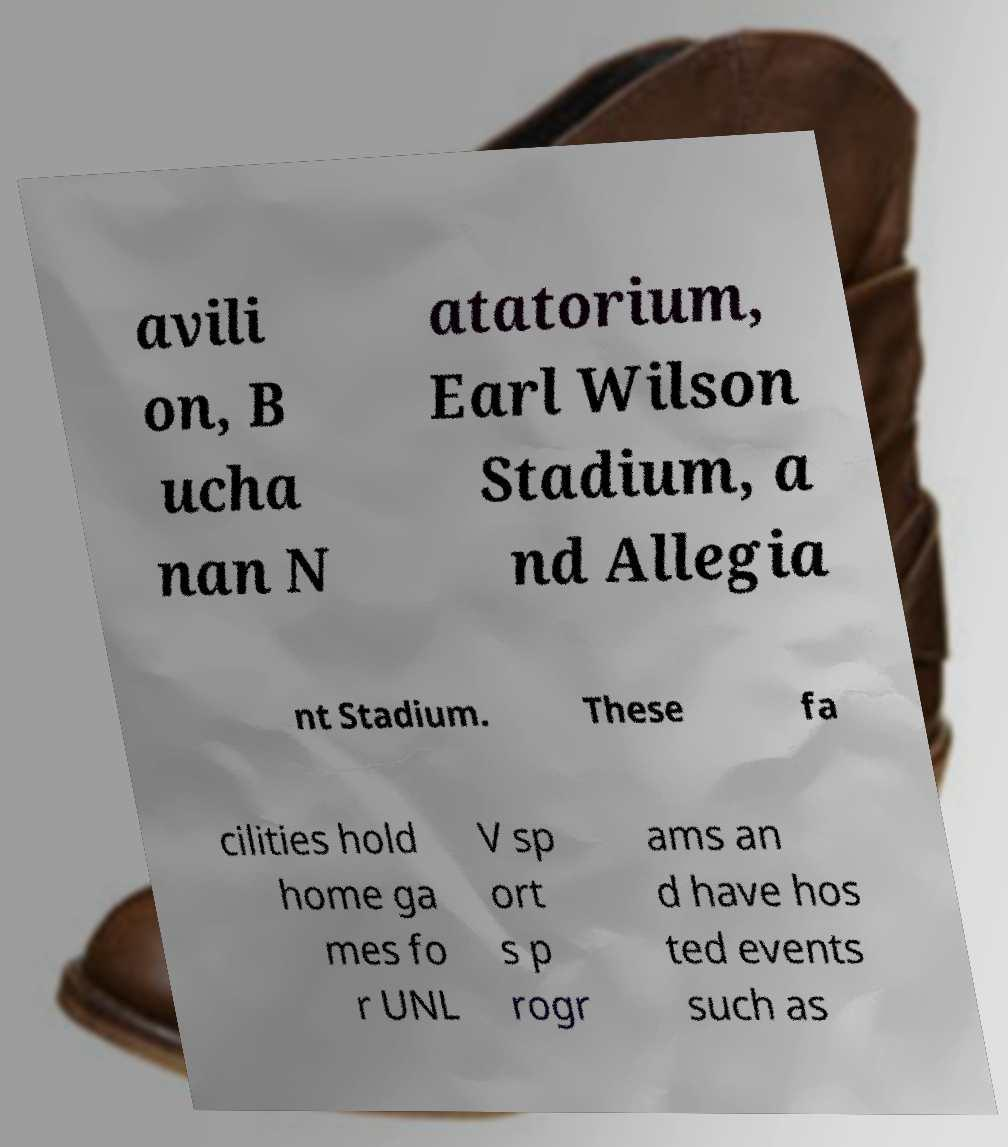Could you assist in decoding the text presented in this image and type it out clearly? avili on, B ucha nan N atatorium, Earl Wilson Stadium, a nd Allegia nt Stadium. These fa cilities hold home ga mes fo r UNL V sp ort s p rogr ams an d have hos ted events such as 